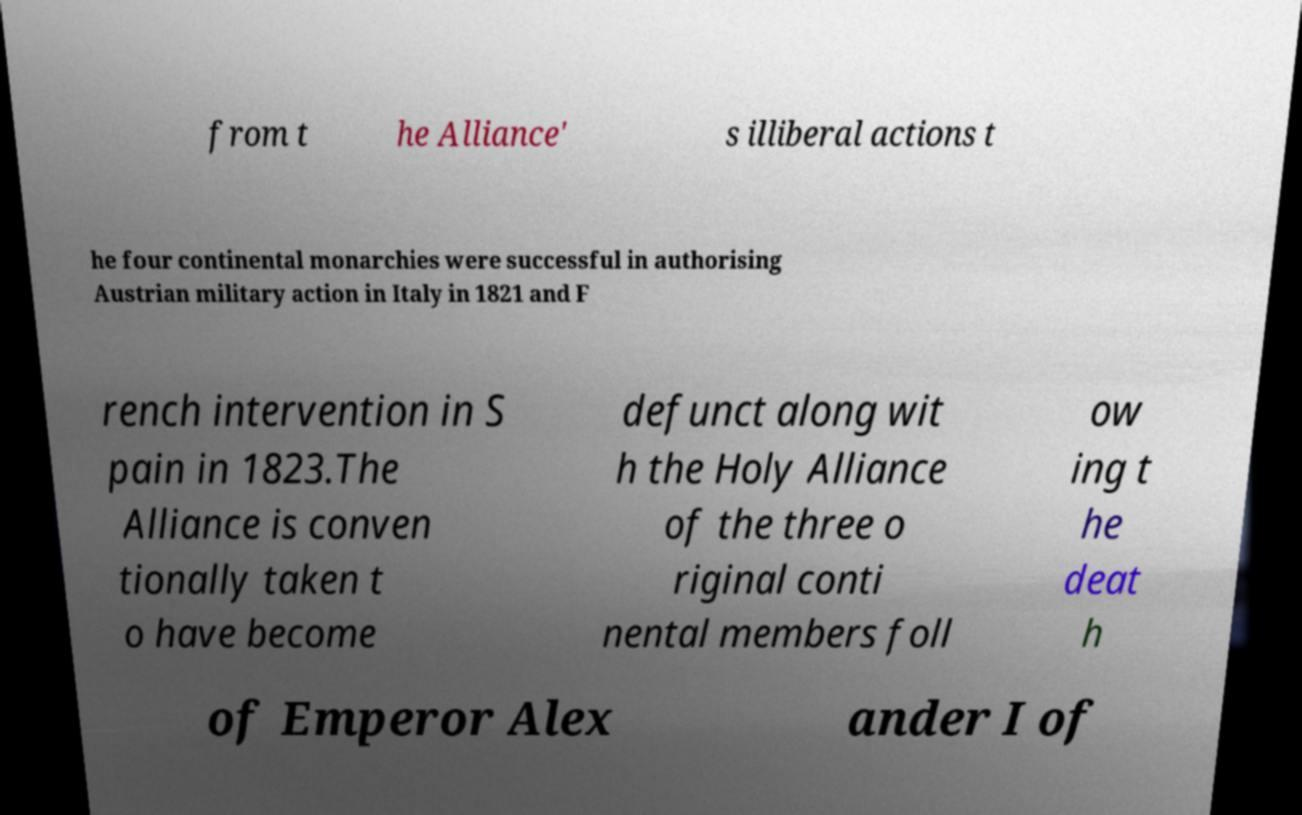Could you assist in decoding the text presented in this image and type it out clearly? from t he Alliance' s illiberal actions t he four continental monarchies were successful in authorising Austrian military action in Italy in 1821 and F rench intervention in S pain in 1823.The Alliance is conven tionally taken t o have become defunct along wit h the Holy Alliance of the three o riginal conti nental members foll ow ing t he deat h of Emperor Alex ander I of 